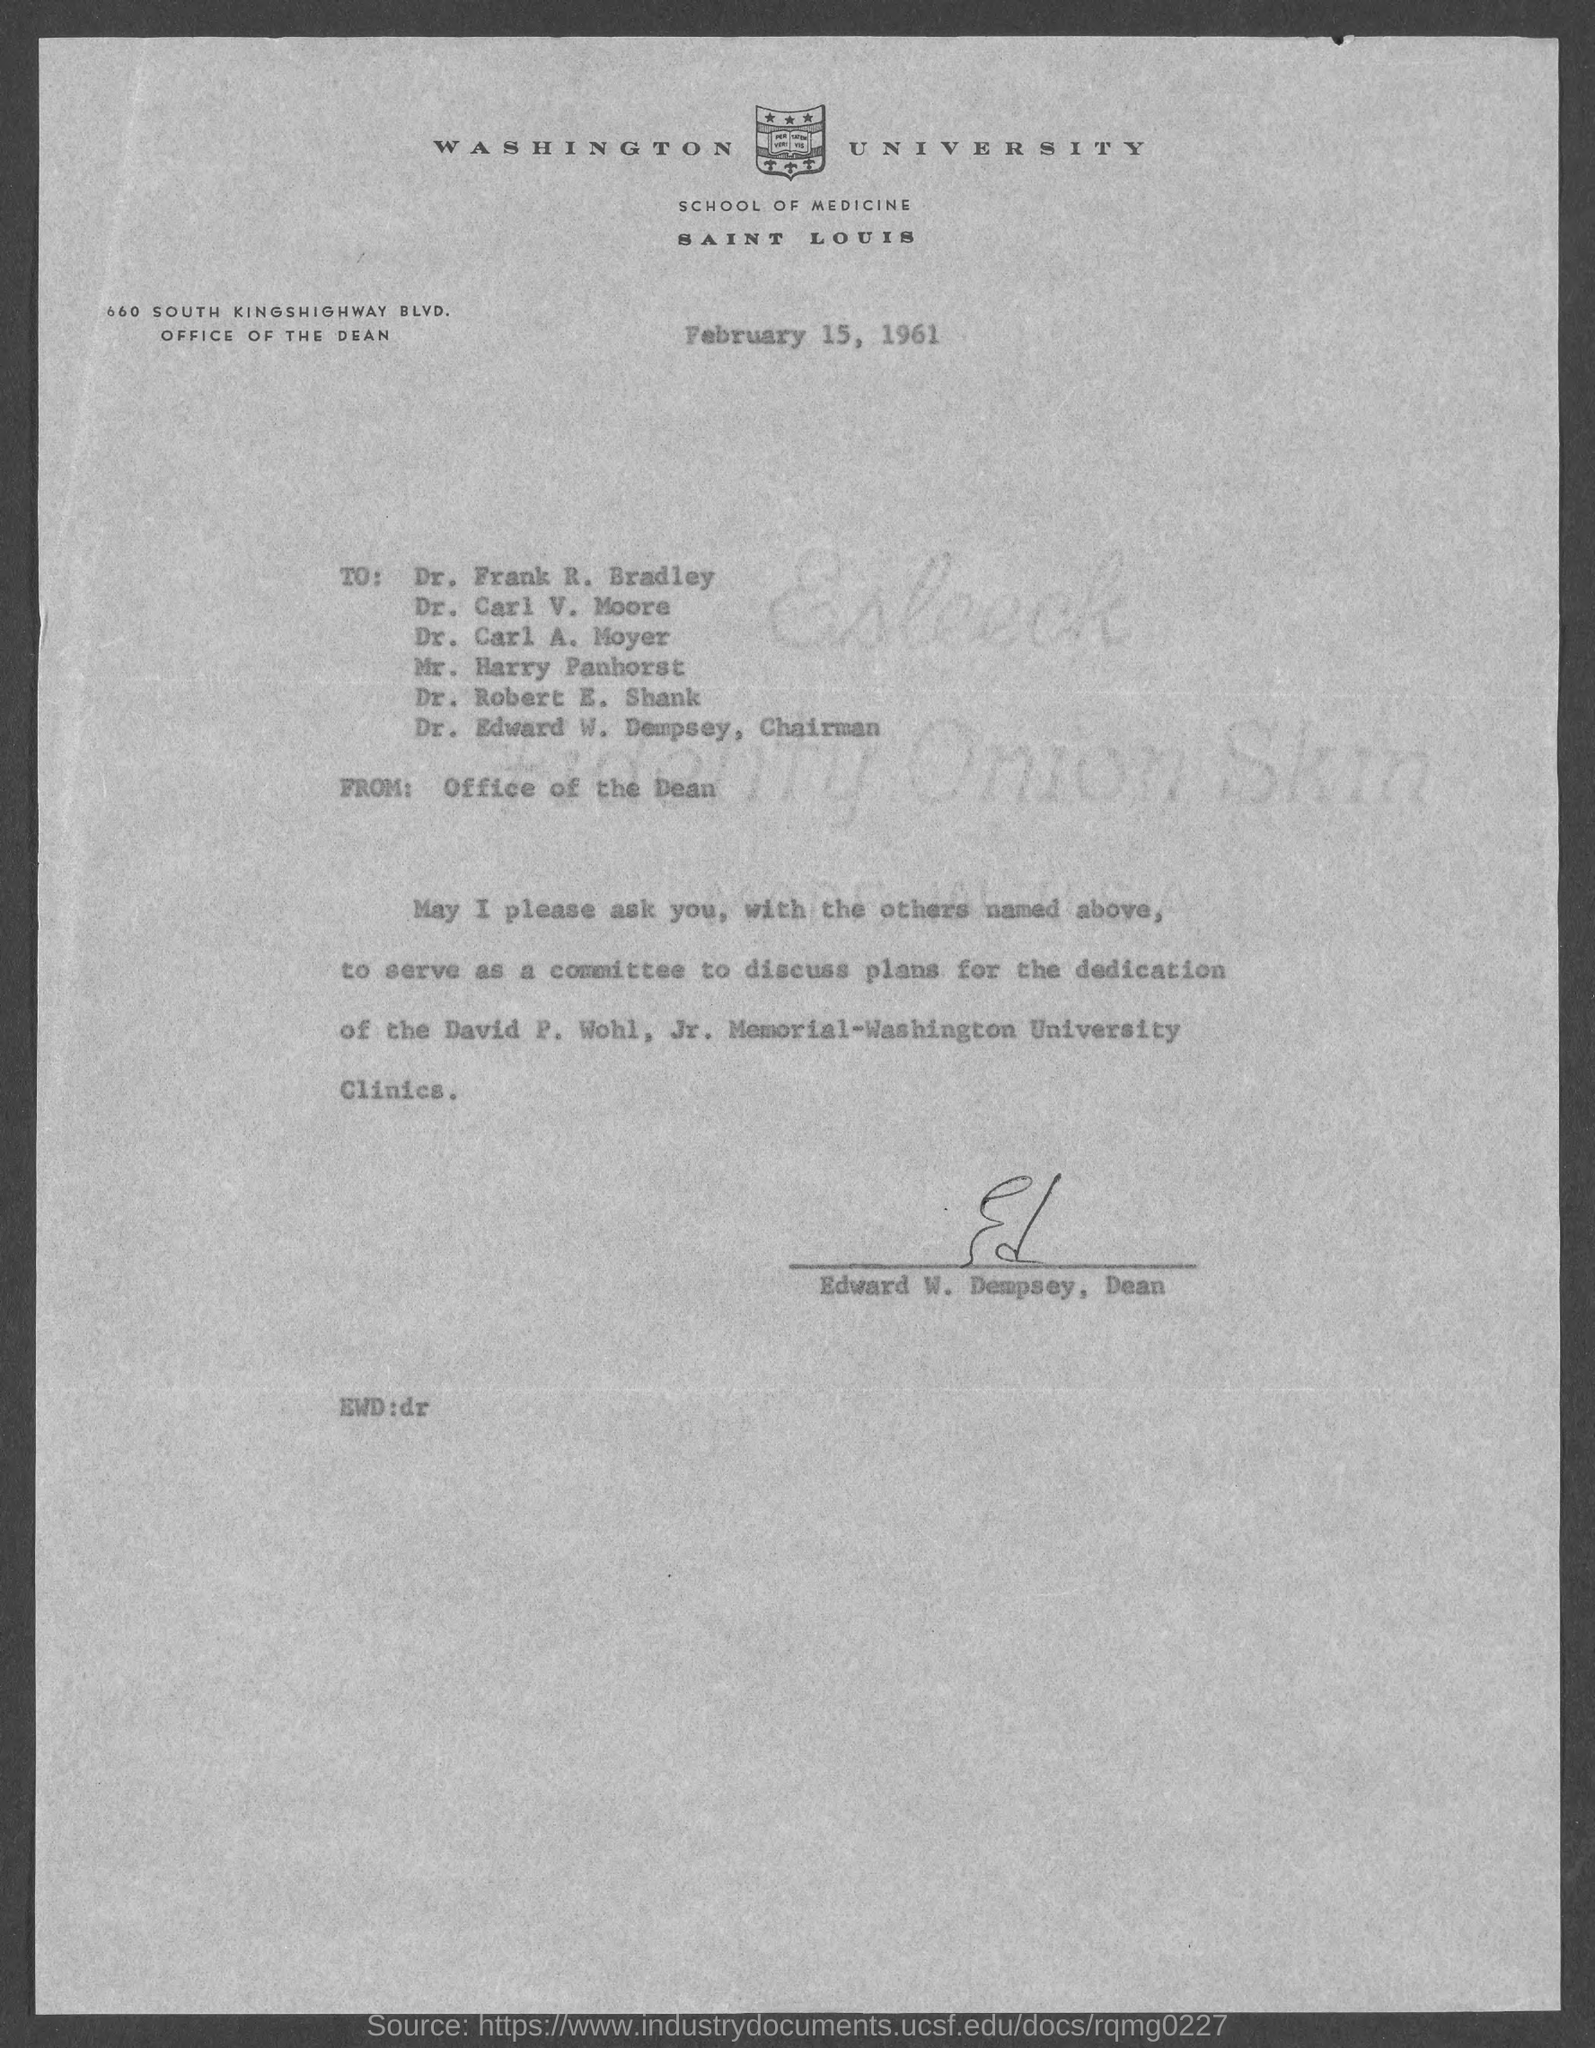Who is the dean, washington university ?
Offer a very short reply. Edward w. dempsey. When is the letter dated ?
Give a very brief answer. February 15, 1961. 